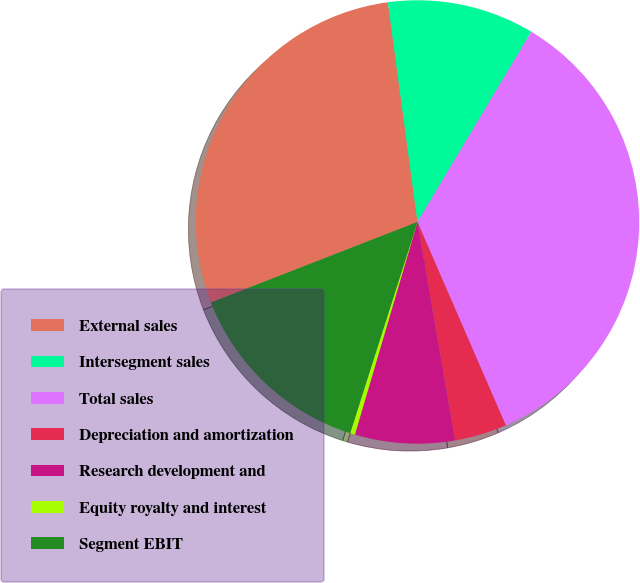Convert chart to OTSL. <chart><loc_0><loc_0><loc_500><loc_500><pie_chart><fcel>External sales<fcel>Intersegment sales<fcel>Total sales<fcel>Depreciation and amortization<fcel>Research development and<fcel>Equity royalty and interest<fcel>Segment EBIT<nl><fcel>28.78%<fcel>10.72%<fcel>34.89%<fcel>3.81%<fcel>7.27%<fcel>0.36%<fcel>14.17%<nl></chart> 